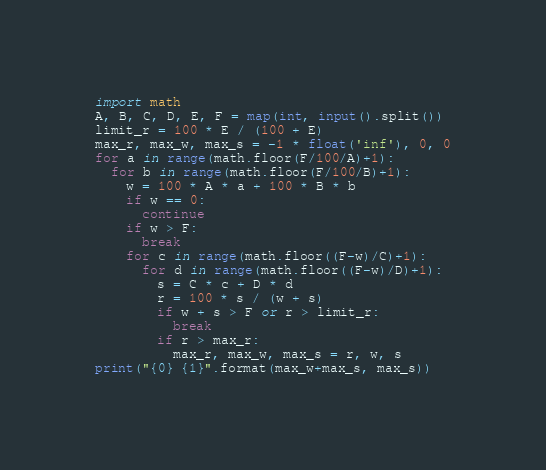<code> <loc_0><loc_0><loc_500><loc_500><_Python_>import math
A, B, C, D, E, F = map(int, input().split())
limit_r = 100 * E / (100 + E)
max_r, max_w, max_s = -1 * float('inf'), 0, 0
for a in range(math.floor(F/100/A)+1):
  for b in range(math.floor(F/100/B)+1):
    w = 100 * A * a + 100 * B * b
    if w == 0:
      continue
    if w > F:
      break
    for c in range(math.floor((F-w)/C)+1):
      for d in range(math.floor((F-w)/D)+1):
        s = C * c + D * d
        r = 100 * s / (w + s)
        if w + s > F or r > limit_r:
          break
        if r > max_r:
          max_r, max_w, max_s = r, w, s
print("{0} {1}".format(max_w+max_s, max_s))
</code> 